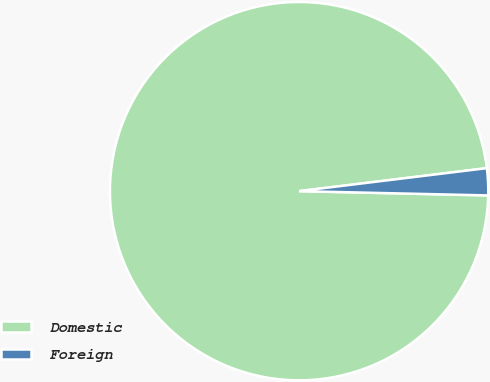Convert chart to OTSL. <chart><loc_0><loc_0><loc_500><loc_500><pie_chart><fcel>Domestic<fcel>Foreign<nl><fcel>97.7%<fcel>2.3%<nl></chart> 